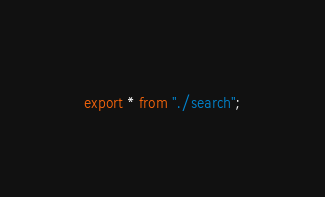<code> <loc_0><loc_0><loc_500><loc_500><_TypeScript_>export * from "./search";
</code> 